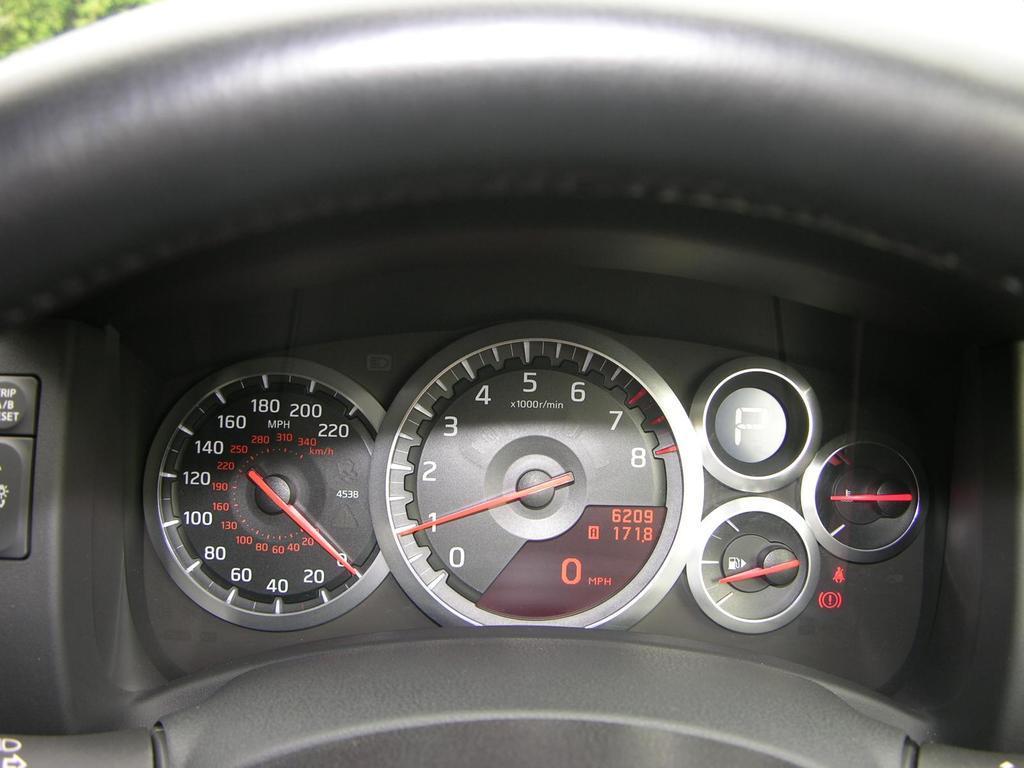In one or two sentences, can you explain what this image depicts? In the picture we can see a part of steering which is black in color and under it we can see speed-o-meter and fuel indicator meter. 